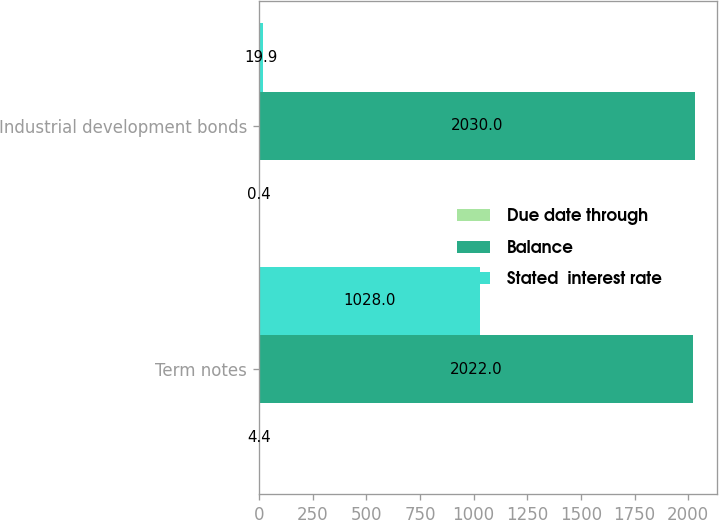Convert chart. <chart><loc_0><loc_0><loc_500><loc_500><stacked_bar_chart><ecel><fcel>Term notes<fcel>Industrial development bonds<nl><fcel>Due date through<fcel>4.4<fcel>0.4<nl><fcel>Balance<fcel>2022<fcel>2030<nl><fcel>Stated  interest rate<fcel>1028<fcel>19.9<nl></chart> 